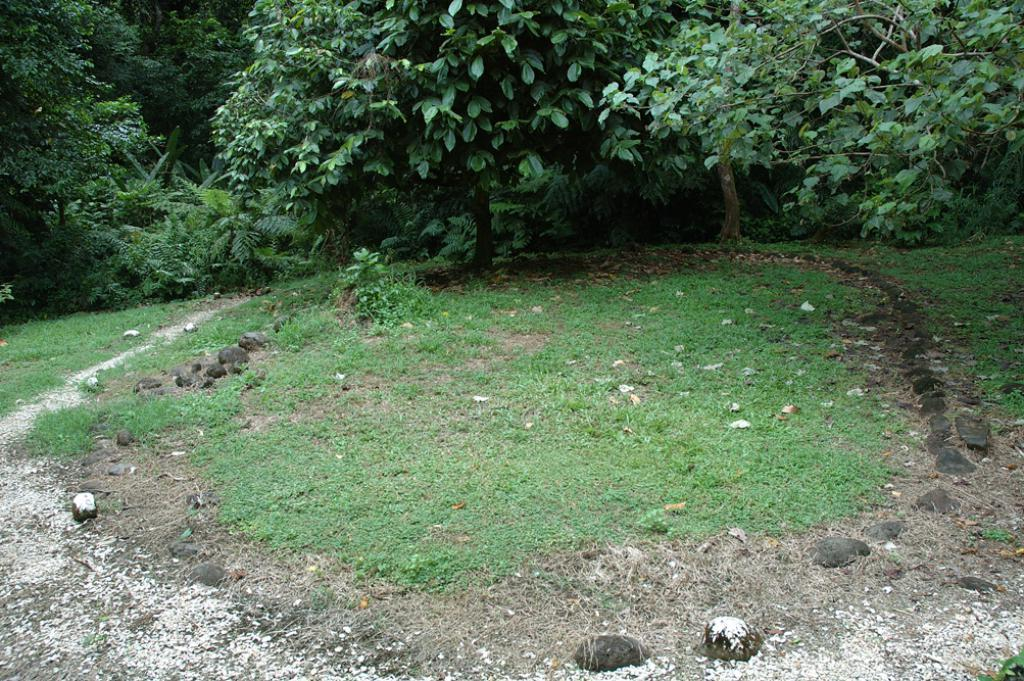What type of vegetation can be seen at the bottom of the image? There are plants and grass at the bottom of the image. What other objects are present at the bottom of the image? There are stones at the bottom of the image. What type of terrain is visible at the bottom of the image? There is land at the bottom of the image. What type of vegetation can be seen at the top of the image? There are trees at the top of the image. How many clams can be seen crawling on the stones in the image? There are no clams present in the image; it features plants, grass, stones, land, and trees. What type of battle is taking place in the image? There is no battle depicted in the image; it is a landscape featuring plants, grass, stones, land, and trees. 